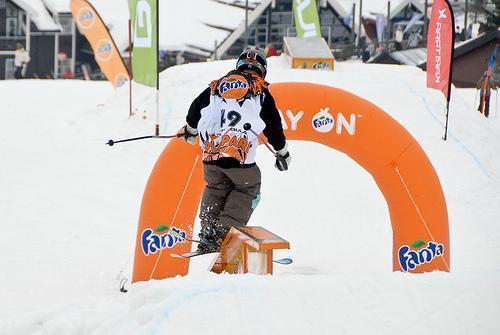How many people are there?
Give a very brief answer. 1. How many people are in this picture?
Give a very brief answer. 1. 